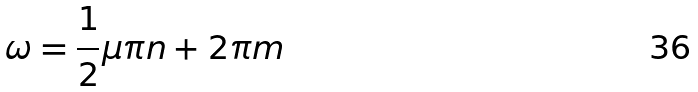<formula> <loc_0><loc_0><loc_500><loc_500>\omega = \frac { 1 } { 2 } \mu \pi n + 2 \pi m</formula> 